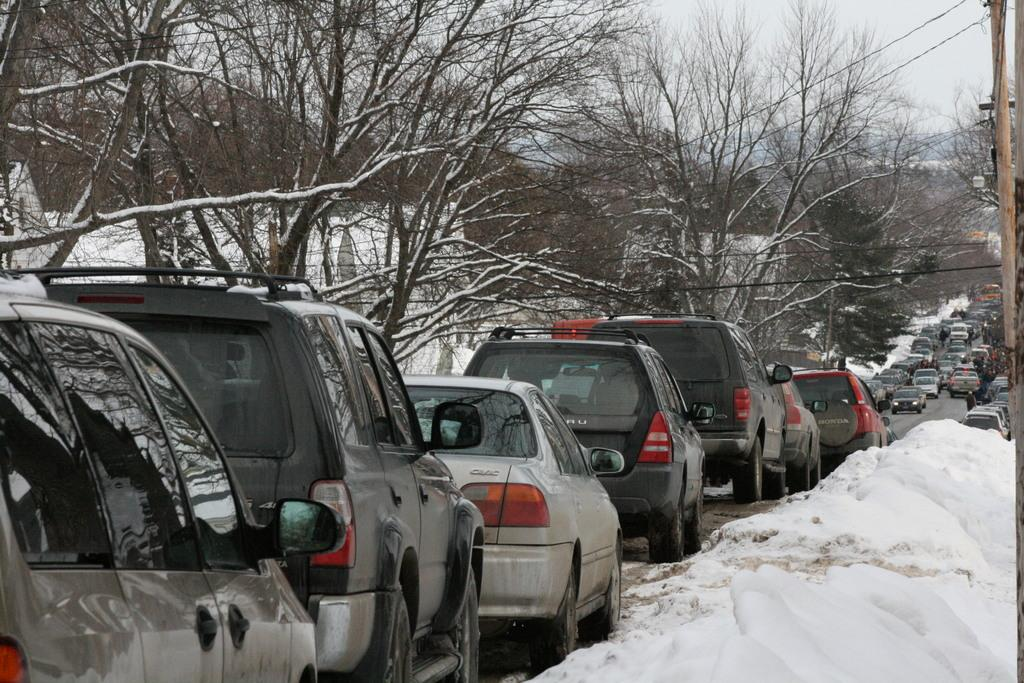What can be seen in the foreground of the picture? In the foreground of the picture, there are cars, snow, a pole, and cables. What type of vegetation is present in the picture? There are trees in the picture. What is the condition of the road in the picture? There are cars on the road in the picture, indicating that it is a snowy day. Is there is snow in the picture, where is it located? Snow is present in both the foreground and the rest of the picture. What type of cabbage is growing on the pole in the picture? There is no cabbage present in the picture; the pole is surrounded by snow and cables. What statement can be made about the hole in the picture? There is no hole present in the picture; the image features a pole, cables, snow, trees, and cars. 